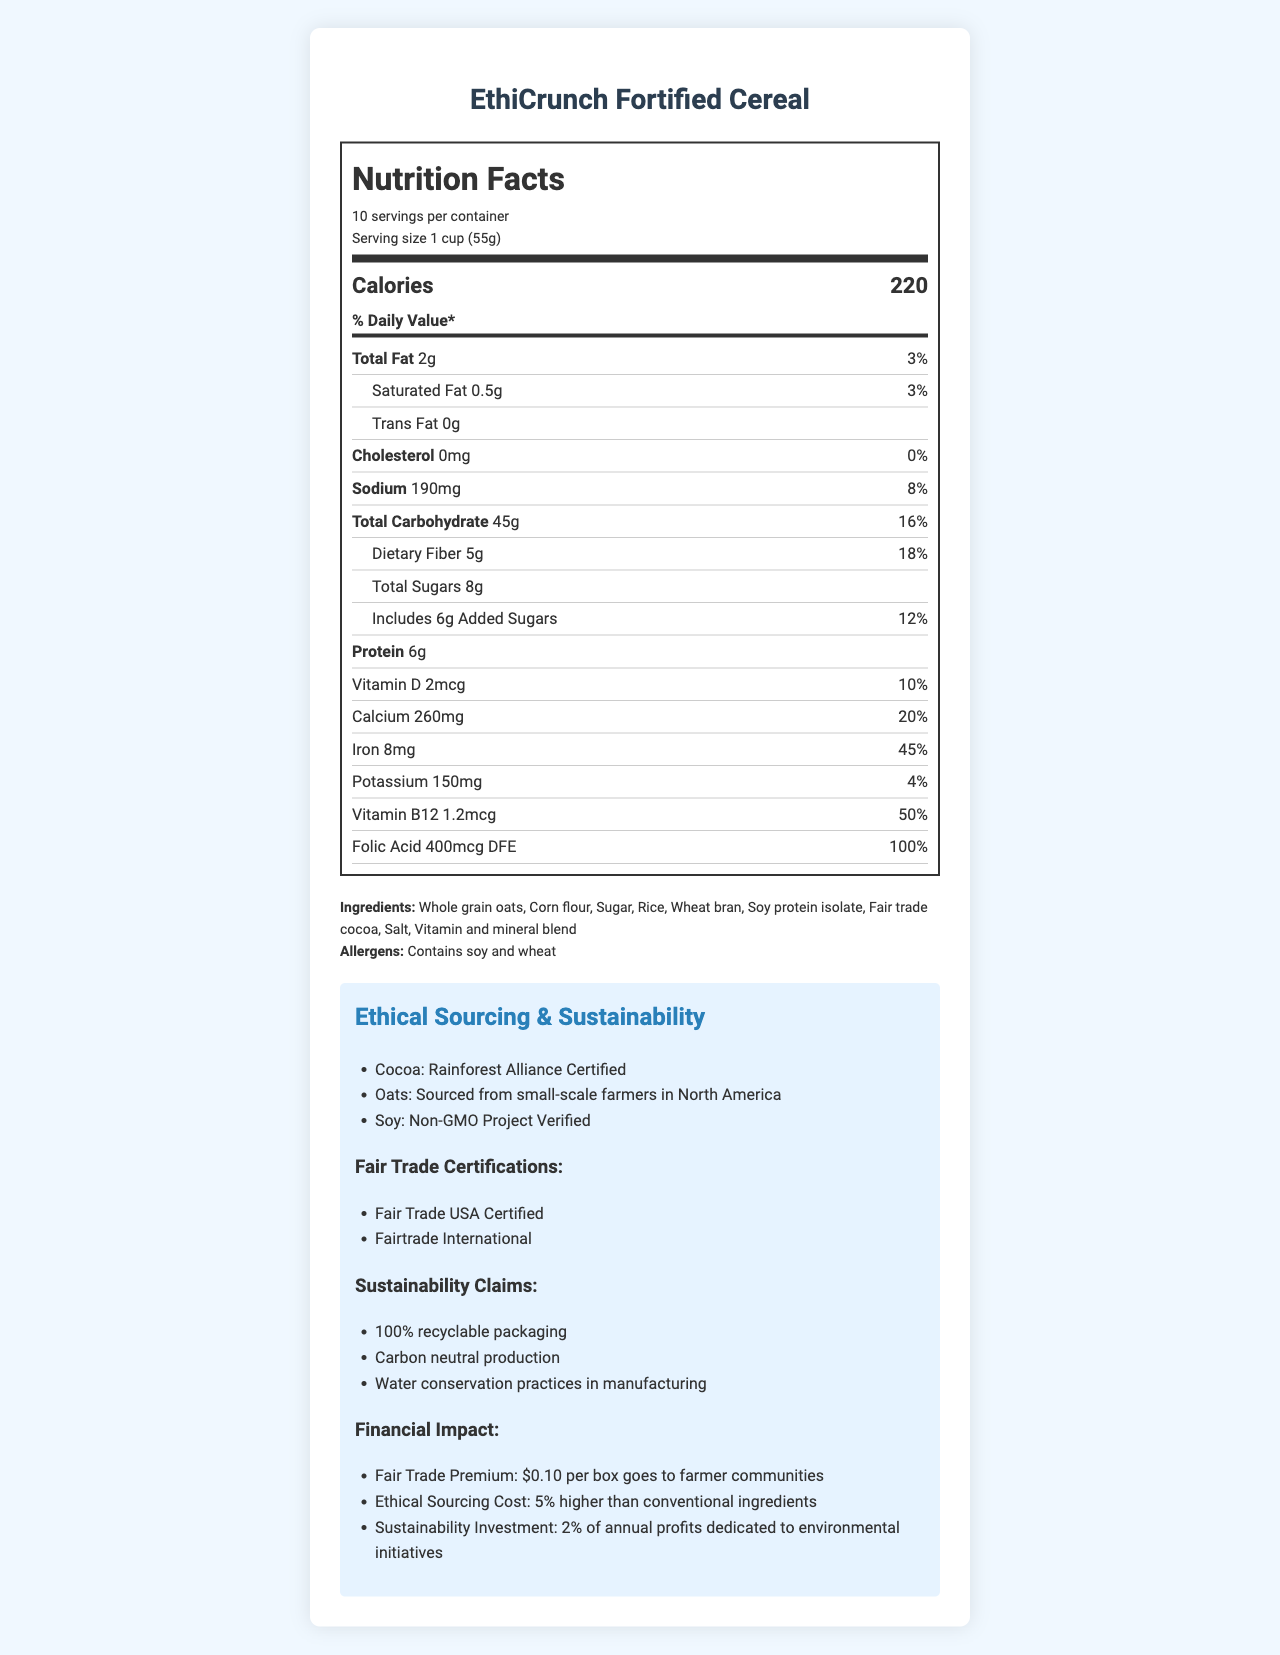what is the serving size for EthiCrunch Fortified Cereal? The serving size is explicitly mentioned under the serving information section in the nutrition facts label.
Answer: 1 cup (55g) how many servings are in one container of EthiCrunch Fortified Cereal? The servings per container information is displayed at the top of the nutrition facts label.
Answer: 10 what is the total fat content per serving? The total fat content is listed in the nutrient section under "Total Fat".
Answer: 2g what sustainability claims does EthiCrunch Fortified Cereal make? The sustainability claims are listed in the ethical sourcing and sustainability section.
Answer: 100% recyclable packaging, Carbon neutral production, Water conservation practices in manufacturing what certifications does this product have regarding fair trade? The fair trade certifications are listed in the ethical sourcing and sustainability section.
Answer: Fair Trade USA Certified, Fairtrade International which of the following nutrients has the highest daily value percentage? A. Vitamin B12 B. Iron C. Calcium D. Sodium Iron has a daily value of 45%, which is the highest compared to the other listed nutrients: Vitamin B12 (50%), Iron (45%), Calcium (20%), and Sodium (8%).
Answer: B. Iron what is the amount of dietary fiber per serving? A. 3g B. 5g C. 8g D. 10g Dietary fiber amount is specifically listed in the nutrient section under "Dietary Fiber" with an amount of 5g per serving.
Answer: B. 5g does EthiCrunch Fortified Cereal contain any trans fat? The trans fat content is explicitly listed as 0g in the nutrient section.
Answer: No summarize the key nutritional information and ethical practices of EthiCrunch Fortified Cereal. The response covers key nutritional values and specifically highlights its ethical sourcing and sustainability practices mentioned in the document.
Answer: EthiCrunch Fortified Cereal provides 220 calories per serving with 2g of total fat, 45g of carbohydrates, 5g of fiber, and 6g of protein. Ethically, it is made with Rainforest Alliance Certified cocoa, non-GMO soy, and oats from small-scale farmers. Additionally, it has Fair Trade USA and Fairtrade International certifications, and claims 100% recyclable packaging, carbon-neutral production, and water conservation practices in manufacturing. what is the primary vitamin supplied by EthiCrunch Fortified Cereal that has the highest daily value percentage? Folic acid has a daily value of 100%, which is the highest among the listed vitamins and minerals in the document.
Answer: Folic Acid what is the amount of protein per serving? The protein content per serving is clearly listed in the nutrient section under "Protein".
Answer: 6g how much vitamin D does the cereal contain per serving and its daily value percentage? The document lists Vitamin D content as 2mcg per serving, with a daily value percentage of 10%.
Answer: 2mcg, 10% does the product contain any allergens? The allergens section lists "Contains soy and wheat" clearly under the ingredients and allergens section.
Answer: Yes, Contains soy and wheat what is the cost premium per box for fair trade practices? The fair trade premium is explicitly stated under the financial impact section.
Answer: $0.10 per box goes to farmer communities describe the primary audiences or consumer groups that this product might appeal to based on the document. Based on the document, the product appeals to multiple target audiences due to its nutritional benefits, fair trade and ethical sourcing practices, and sustainability claims.
Answer: Health-conscious consumers, ethically-minded buyers, environmentally-conscious consumers, and those specifically looking for fortified nutritional options 